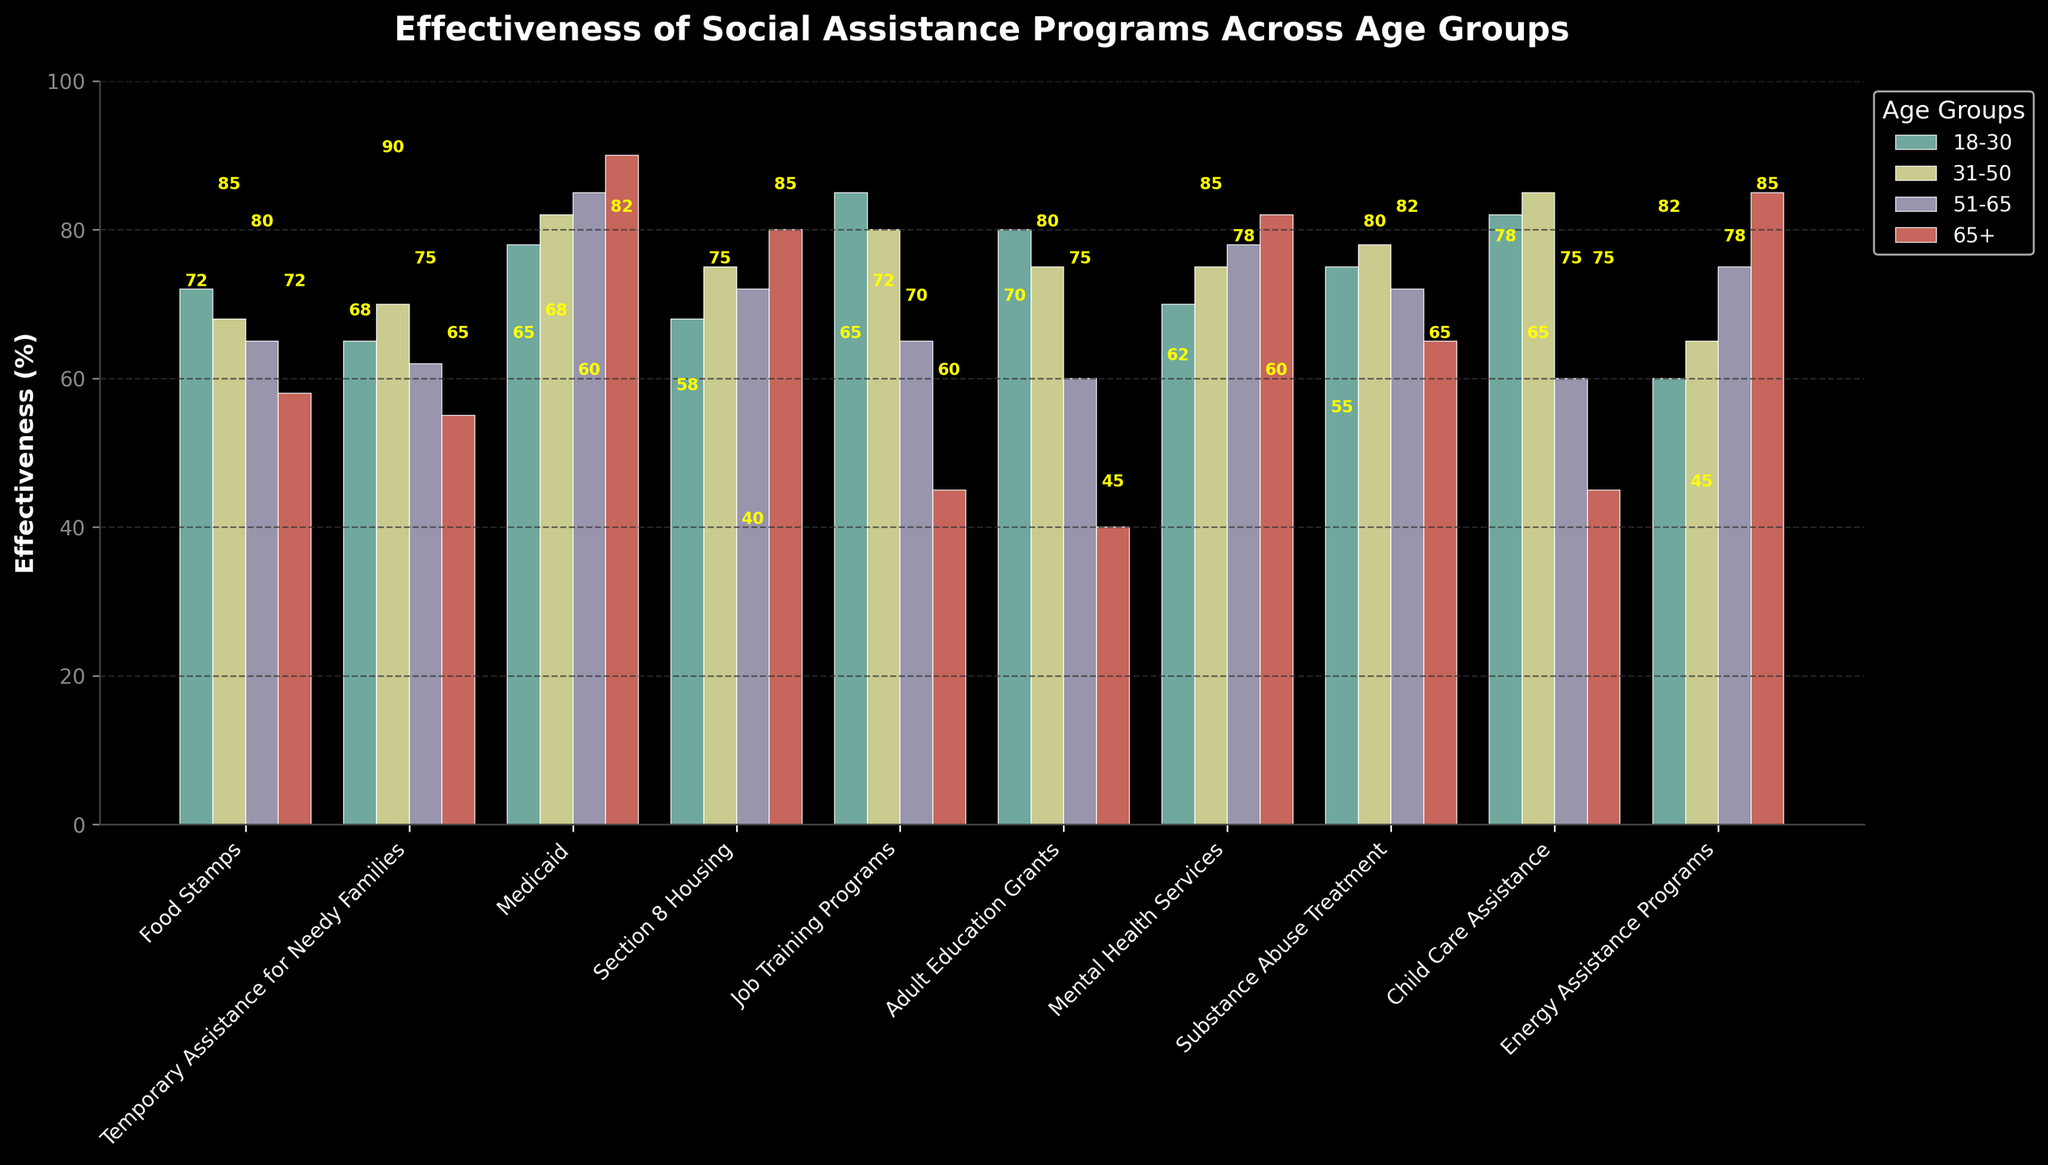Which age group perceives "Medicaid" as the most effective? To determine which age group perceives "Medicaid" as the most effective, we look for the highest effectiveness percentage for "Medicaid" across all age groups. The values are 78, 82, 85, and 90. Hence, the highest value (90%) is associated with the age group 65+.
Answer: 65+ Compare the effectiveness of "Food Stamps" for the 18-30 and 65+ age groups. Which group finds it more effective? To compare the effectiveness of "Food Stamps" for the 18-30 and 65+ age groups, we examine the bars representing these groups. The 18-30 age group has a value of 72, and the 65+ age group has a value of 58. Therefore, the 18-30 age group finds it more effective.
Answer: 18-30 What is the difference in effectiveness between "Job Training Programs" for the 18-30 and 65+ age groups? To find the difference in effectiveness between "Job Training Programs" for the 18-30 and 65+ age groups, we subtract the value for the 65+ age group (45) from the value for the 18-30 age group (85). The calculation is 85 - 45.
Answer: 40 Among all social assistance programs, which program shows the highest effectiveness for the 31-50 age group? We examine the bars for all programs within the 31-50 age group and identify the program with the highest value. "Child Care Assistance" has the highest value of 85%.
Answer: Child Care Assistance What is the average effectiveness of "Adult Education Grants" across all age groups? To find the average effectiveness of "Adult Education Grants" across all age groups, we sum up the values (80, 75, 60, 40) and divide by the number of age groups (4). The calculation is (80 + 75 + 60 + 40) / 4.
Answer: 63.75 Which assistance program has the most uniform effectiveness across all age groups? To find the program with the most uniform effectiveness, we look for the smallest range of values across all age groups for each program. The ranges are Food Stamps (72-58=14), Temporary Assistance for Needy Families (70-55=15), Medicaid (90-78=12), Section 8 Housing (80-68=12), Job Training Programs (85-45=40), Adult Education Grants (80-40=40), Mental Health Services (82-70=12), Substance Abuse Treatment (78-65=13), Child Care Assistance (85-45=40), Energy Assistance Programs (85-60=25). "Section 8 Housing," "Mental Health Services," and "Medicaid" all have the smallest range of 12.
Answer: Medicaid, Section 8 Housing, Mental Health Services What can you infer about the effectiveness of "Energy Assistance Programs" over age? Observing "Energy Assistance Programs" across all age groups, we see increasing effectiveness from 18-30 (60) to 65+ (85). This suggests perception may improve with age.
Answer: Increasing with age How much more effective is "Mental Health Services" for the 65+ age group than "Job Training Programs" for the same group? To determine how much more effective "Mental Health Services" is for the 65+ age group than "Job Training Programs," we subtract the value for "Job Training Programs" (45) from the value for "Mental Health Services" (82). The calculation is 82 - 45.
Answer: 37 